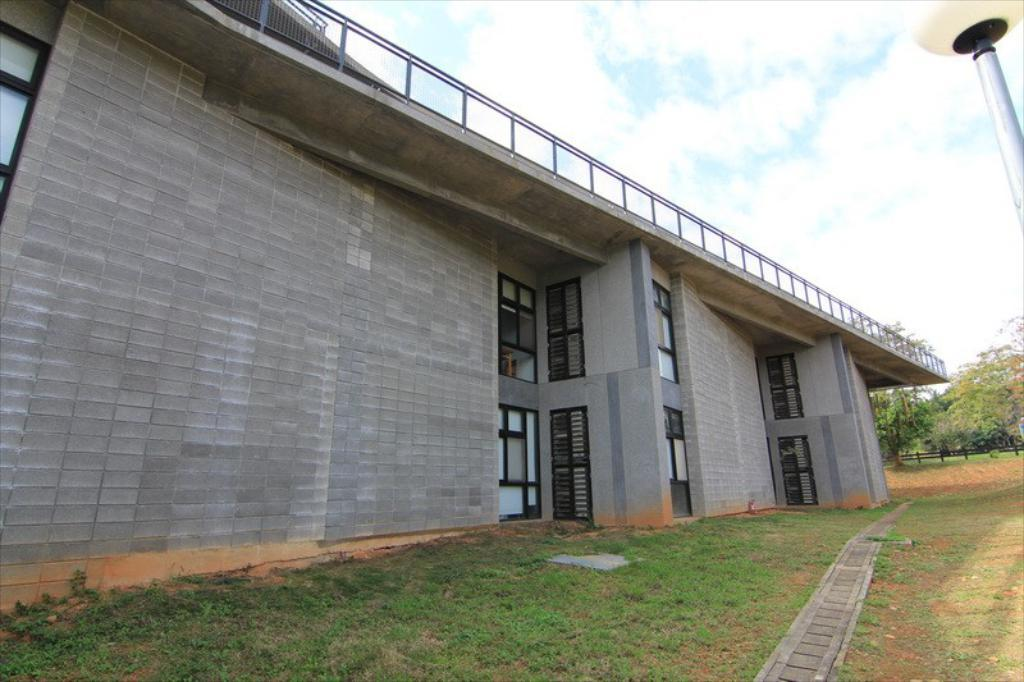What structure is located on the left side of the image? There is a building on the left side of the image. What features can be seen on the building? The building has doors and windows. What is the purpose of the image? The image shows a building with doors and windows, a fence, a pole, trees, and the sky. What is the purpose of the pole on the left side of the image? The purpose of the pole is not specified in the image, but it could be for signage, lighting, or other purposes. What type of vegetation is visible at the back of the image? There are trees at the back of the image. What is visible at the top of the image? The sky is visible at the top of the image. What type of blade is being used to trim the growth on the trees in the image? There is no blade or growth visible on the trees in the image. What type of mitten is being worn by the person in the image? There is no person or mitten present in the image. 